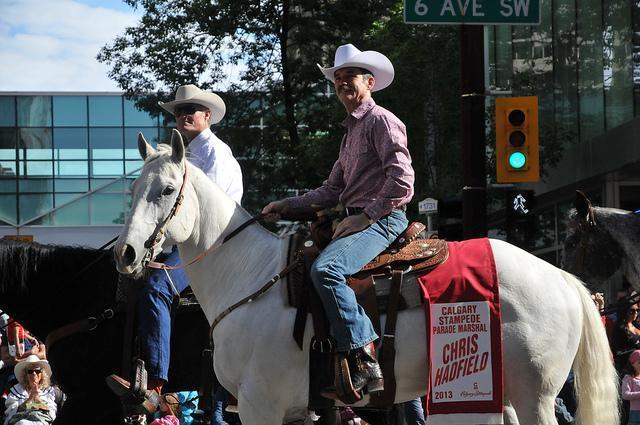How many horses are there?
Give a very brief answer. 3. How many people are there?
Give a very brief answer. 3. How many remotes are on the table?
Give a very brief answer. 0. 